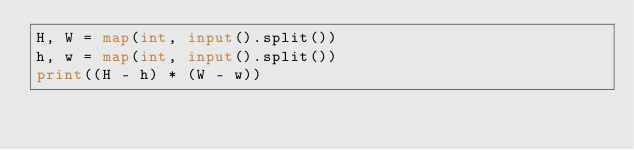<code> <loc_0><loc_0><loc_500><loc_500><_Python_>H, W = map(int, input().split())
h, w = map(int, input().split())
print((H - h) * (W - w))
</code> 